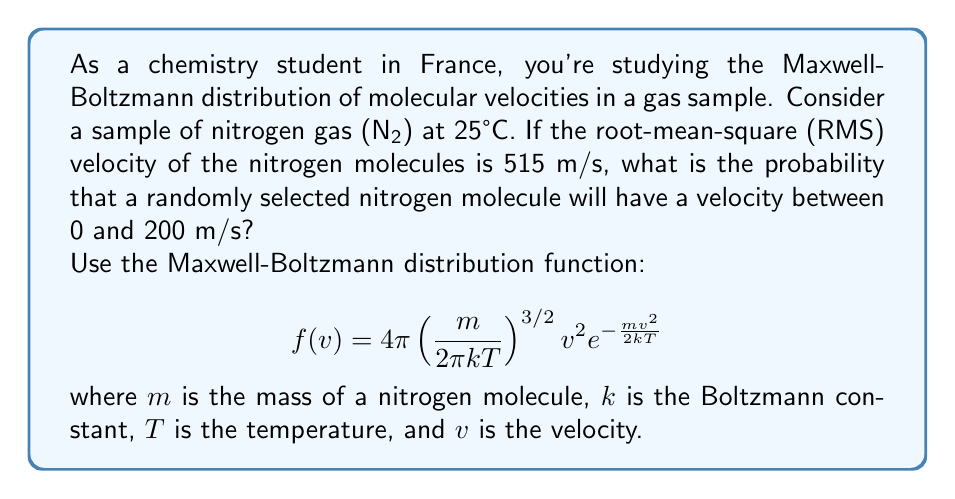Can you solve this math problem? Let's approach this step-by-step:

1) First, we need to find the mass of a nitrogen molecule:
   $m = 2 \times 14 \times 1.66 \times 10^{-27} = 4.65 \times 10^{-26}$ kg

2) We know that $T = 25°C = 298.15$ K

3) The Boltzmann constant $k = 1.38 \times 10^{-23}$ J/K

4) We're given that the RMS velocity is 515 m/s. We can use this to verify our calculations:
   $$ v_{rms} = \sqrt{\frac{3kT}{m}} = \sqrt{\frac{3 \times 1.38 \times 10^{-23} \times 298.15}{4.65 \times 10^{-26}}} = 515 \text{ m/s} $$

5) Now, we need to integrate the Maxwell-Boltzmann distribution from 0 to 200 m/s:

   $$ P(0 \leq v \leq 200) = \int_0^{200} 4\pi \left( \frac{m}{2\pi kT} \right)^{3/2} v^2 e^{-\frac{mv^2}{2kT}} dv $$

6) This integral doesn't have a simple analytical solution, so we need to use numerical integration methods. Using a computer algebra system or numerical integration tool, we find:

   $$ P(0 \leq v \leq 200) \approx 0.0398 $$

Therefore, the probability that a randomly selected nitrogen molecule will have a velocity between 0 and 200 m/s is approximately 0.0398 or 3.98%.
Answer: 0.0398 or 3.98% 